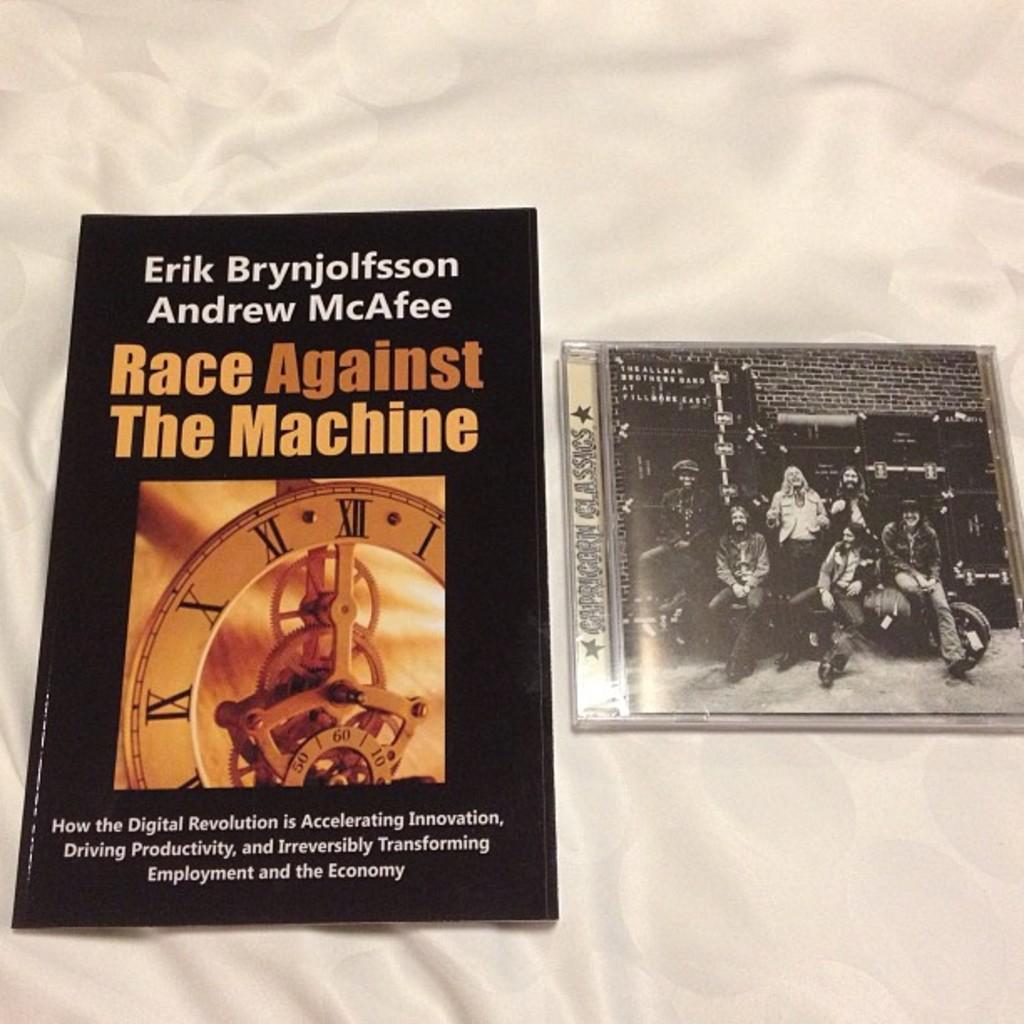What is the title?
Offer a very short reply. Race against the machine. What are some things being effected by the digital revolution?
Your answer should be very brief. Accelerating innovation. 